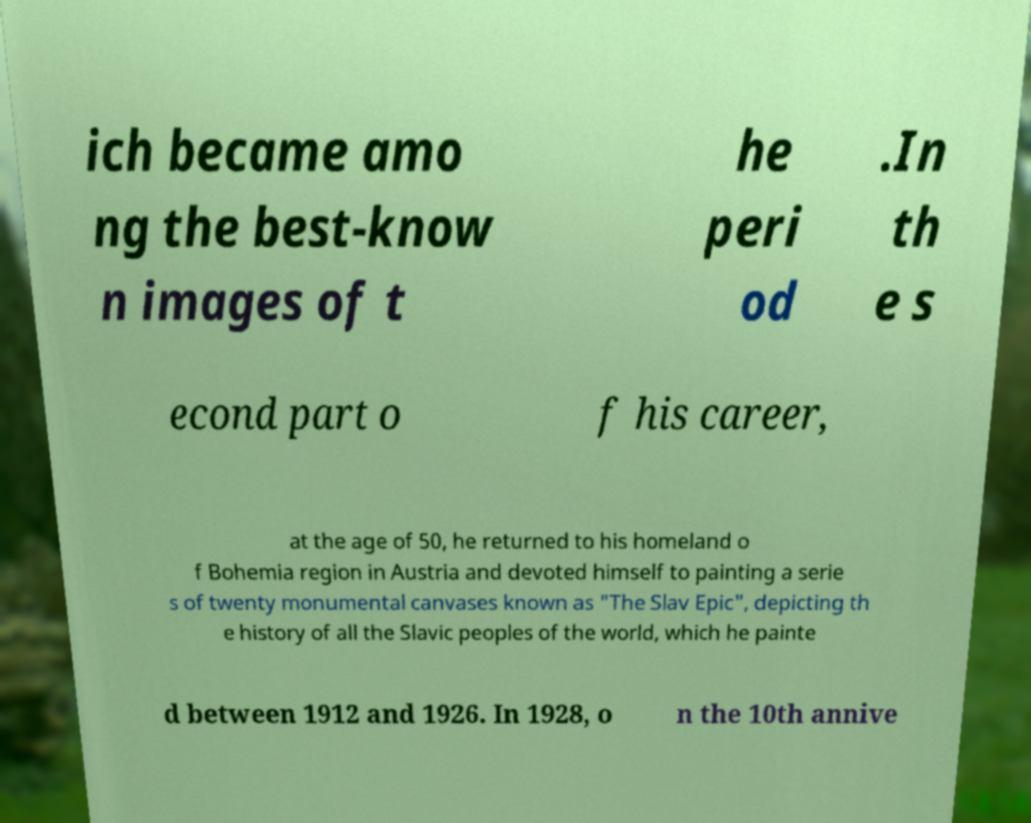Please identify and transcribe the text found in this image. ich became amo ng the best-know n images of t he peri od .In th e s econd part o f his career, at the age of 50, he returned to his homeland o f Bohemia region in Austria and devoted himself to painting a serie s of twenty monumental canvases known as "The Slav Epic", depicting th e history of all the Slavic peoples of the world, which he painte d between 1912 and 1926. In 1928, o n the 10th annive 